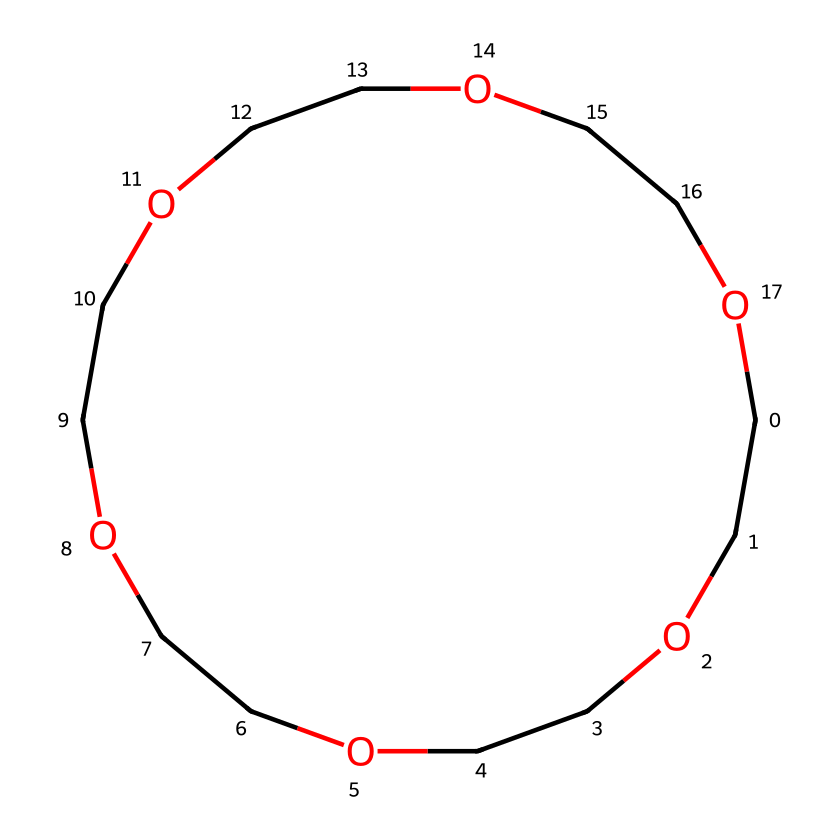What is the total number of oxygen atoms in this compound? The chemical contains a repeating ether structure, where each unit has one oxygen atom. By counting the distinctive ether units in the structure, we find that there are 5 oxygen atoms in total.
Answer: 5 How many carbon atoms are present in the structure? The SMILES notation shows a chain of carbons and oxygens, and counting the carbon atoms, which are represented in the structure, we determine there are 6 carbon atoms.
Answer: 6 What is the name of this chemical compound? This chemical corresponds to a crown ether, specifically 18-crown-6, due to its molecular structure forming a cyclic arrangement of oxygens and carbons.
Answer: 18-crown-6 How many total rings does the chemical structure contain? The structure is a single cyclic arrangement due to its crown ether nature. Thus, the whole structure forms one ring.
Answer: 1 What type of chemical reaction is this compound primarily involved in? Crown ethers like this compound are primarily involved in phase-transfer catalysis, which allows reagents to react in different phases.
Answer: phase-transfer catalysis What is the role of the oxygen atoms in this ether? The oxygen atoms in crown ethers serve to stabilize the molecule and act as electron pair donors, which is crucial for their role in complexing cations in phase-transfer catalysis.
Answer: electron pair donors How does the cyclic nature of this compound affect its solubility? The cyclic structure allows this ether to encapsulate ions, significantly increasing its solubility in organic solvents.
Answer: increases solubility 